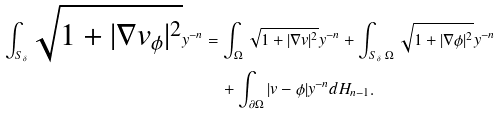Convert formula to latex. <formula><loc_0><loc_0><loc_500><loc_500>\int _ { S _ { \delta } } \sqrt { 1 + | \nabla v _ { \phi } | ^ { 2 } } y ^ { - n } & = \int _ { \Omega } \sqrt { 1 + | \nabla v | ^ { 2 } } y ^ { - n } + \int _ { S _ { \delta } \ \Omega } \sqrt { 1 + | \nabla \phi | ^ { 2 } } y ^ { - n } \\ & \quad + \int _ { \partial \Omega } | v - \phi | y ^ { - n } d H _ { n - 1 } .</formula> 